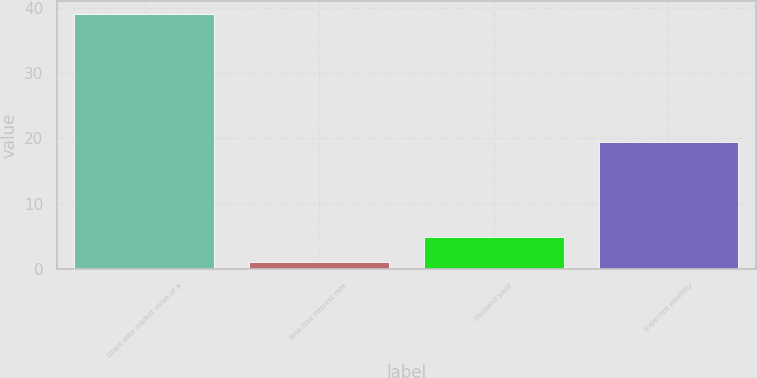Convert chart to OTSL. <chart><loc_0><loc_0><loc_500><loc_500><bar_chart><fcel>Grant date market value of a<fcel>Risk-free interest rate<fcel>Dividend yield<fcel>Expected volatility<nl><fcel>39.05<fcel>1.04<fcel>4.84<fcel>19.48<nl></chart> 